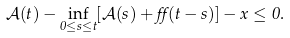Convert formula to latex. <formula><loc_0><loc_0><loc_500><loc_500>\mathcal { A } ( t ) - \inf _ { 0 \leq s \leq t } [ \mathcal { A } ( s ) + \alpha ( t - s ) ] - x \leq 0 .</formula> 